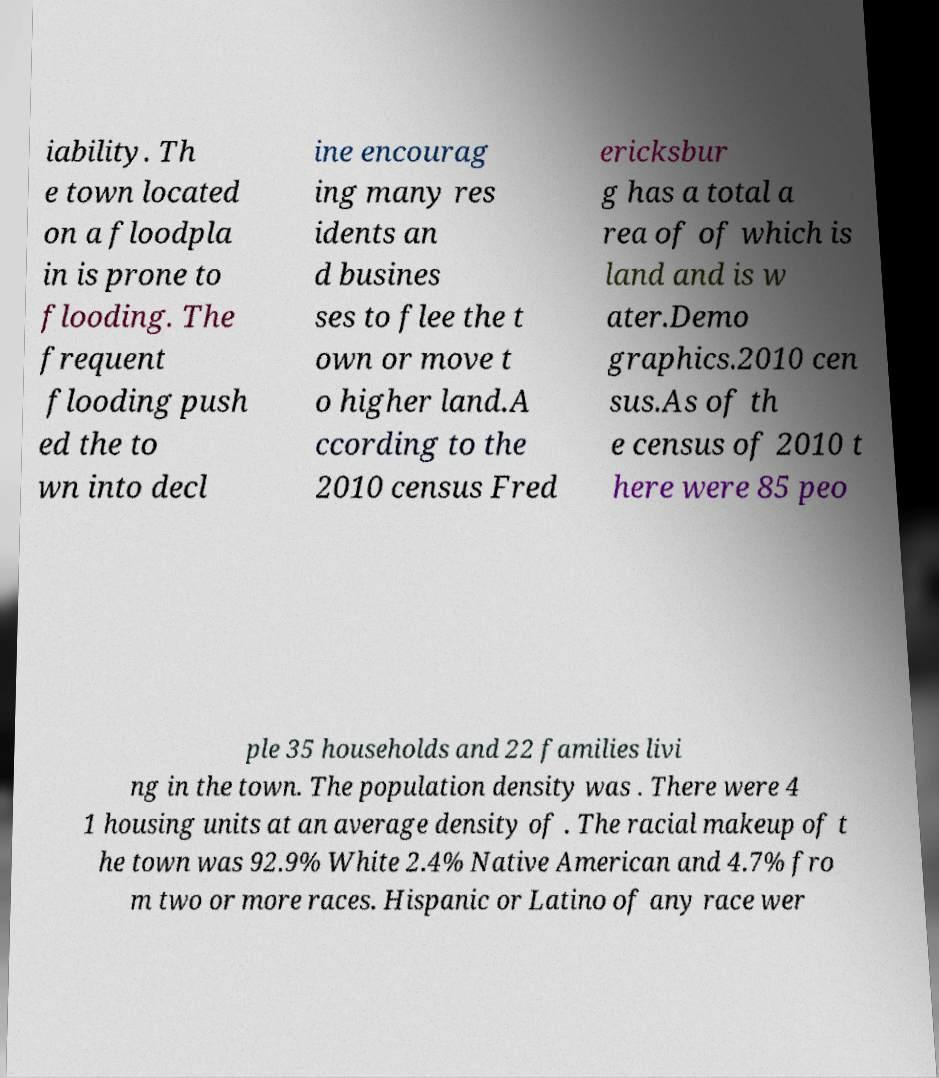Can you accurately transcribe the text from the provided image for me? iability. Th e town located on a floodpla in is prone to flooding. The frequent flooding push ed the to wn into decl ine encourag ing many res idents an d busines ses to flee the t own or move t o higher land.A ccording to the 2010 census Fred ericksbur g has a total a rea of of which is land and is w ater.Demo graphics.2010 cen sus.As of th e census of 2010 t here were 85 peo ple 35 households and 22 families livi ng in the town. The population density was . There were 4 1 housing units at an average density of . The racial makeup of t he town was 92.9% White 2.4% Native American and 4.7% fro m two or more races. Hispanic or Latino of any race wer 